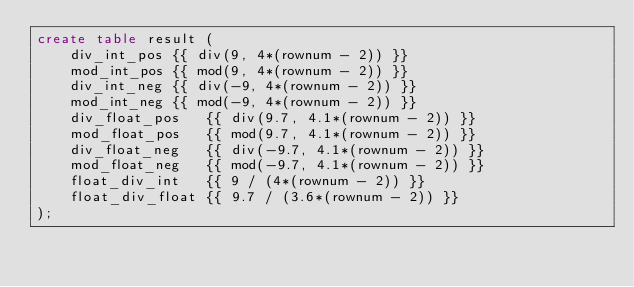Convert code to text. <code><loc_0><loc_0><loc_500><loc_500><_SQL_>create table result (
    div_int_pos {{ div(9, 4*(rownum - 2)) }}
    mod_int_pos {{ mod(9, 4*(rownum - 2)) }}
    div_int_neg {{ div(-9, 4*(rownum - 2)) }}
    mod_int_neg {{ mod(-9, 4*(rownum - 2)) }}
    div_float_pos   {{ div(9.7, 4.1*(rownum - 2)) }}
    mod_float_pos   {{ mod(9.7, 4.1*(rownum - 2)) }}
    div_float_neg   {{ div(-9.7, 4.1*(rownum - 2)) }}
    mod_float_neg   {{ mod(-9.7, 4.1*(rownum - 2)) }}
    float_div_int   {{ 9 / (4*(rownum - 2)) }}
    float_div_float {{ 9.7 / (3.6*(rownum - 2)) }}
);
</code> 